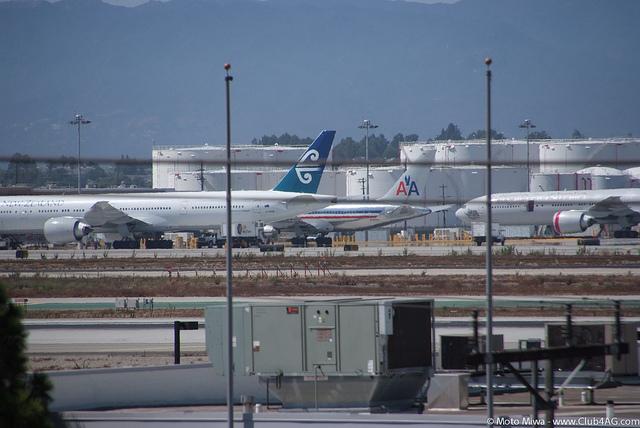What color is the sky?
Keep it brief. Blue. How many planes are there?
Keep it brief. 3. Is there a body of water in the photo?
Write a very short answer. No. Is this daytime?
Give a very brief answer. Yes. Which mode of transport weighs the most?
Short answer required. Airplane. Is this a private or commercial airport?
Short answer required. Commercial. How many buses are there?
Answer briefly. 0. Which of these vehicles would float?
Write a very short answer. None. 